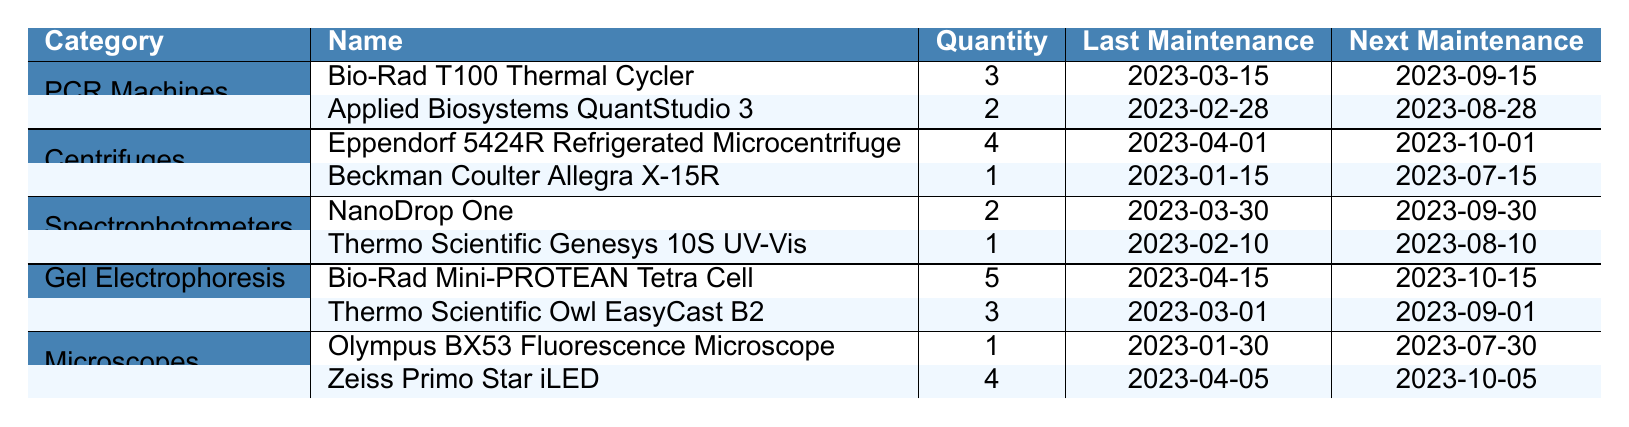What is the quantity of Bio-Rad T100 Thermal Cyclers available? The table states that there are 3 Bio-Rad T100 Thermal Cyclers under the PCR Machines category.
Answer: 3 When is the next maintenance date for the Thermo Scientific Genesys 10S UV-Vis? The next maintenance date for the Thermo Scientific Genesys 10S UV-Vis, listed under Spectrophotometers, is 2023-08-10.
Answer: 2023-08-10 How many PCR machines are listed in total? There are 3 PCR machines (Bio-Rad T100 Thermal Cycler and Applied Biosystems QuantStudio 3) totaling to 2 unique machines, so the total quantity is 3 + 2 = 5.
Answer: 5 Is there a higher quantity of Gel Electrophoresis Systems or Centrifuges? There are 5 Gel Electrophoresis Systems in total (5 from Bio-Rad Mini-PROTEAN and 3 from Thermo Scientific Owl), while there are 4 Centrifuges in total (4 from Eppendorf and 1 from Beckman Coulter). Since 5 > 4, Gel Electrophoresis Systems are more numerous.
Answer: Yes What are the last maintenance dates for all Microscopes listed? The dates for the last maintenance of Microscopes are 2023-01-30 for Olympus BX53 Fluorescence Microscope and 2023-04-05 for Zeiss Primo Star iLED. These can be found in the Microscopes category of the table.
Answer: 2023-01-30 and 2023-04-05 Which equipment category has the highest number of items? The category with the highest number of items is Gel Electrophoresis Systems, with a total quantity of 8 (5 Bio-Rad Mini-PROTEAN + 3 Thermo Scientific Owl). Comparing with other categories, they all have less combined quantities.
Answer: Gel Electrophoresis Systems When is the next maintenance date for Eppendorf 5424R Refrigerated Microcentrifuge? The next maintenance date is defined in the table as 2023-10-01, which can be found under the Centrifuges category for that specific item.
Answer: 2023-10-01 What is the average quantity of equipment per category? The total quantity across all categories is 3 (PCR) + 4 (Centrifuges) + 3 (Spectrophotometers) + 8 (Gel Electrophoresis) + 5 (Microscopes) = 23. There are 5 categories, so the average is 23/5 = 4.6.
Answer: 4.6 Which equipment requires maintenance the soonest? To find out which equipment requires maintenance soonest, check the "Next Maintenance" column. The Beckman Coulter Allegra X-15R has the next maintenance date of 2023-07-15, which is the earliest date in the table.
Answer: Beckman Coulter Allegra X-15R How many total centrifuges are there? The total number of centrifuges is the sum of all listed centrifuge items, which is 4 (Eppendorf 5424R) + 1 (Beckman Coulter Allegra) = 5.
Answer: 5 